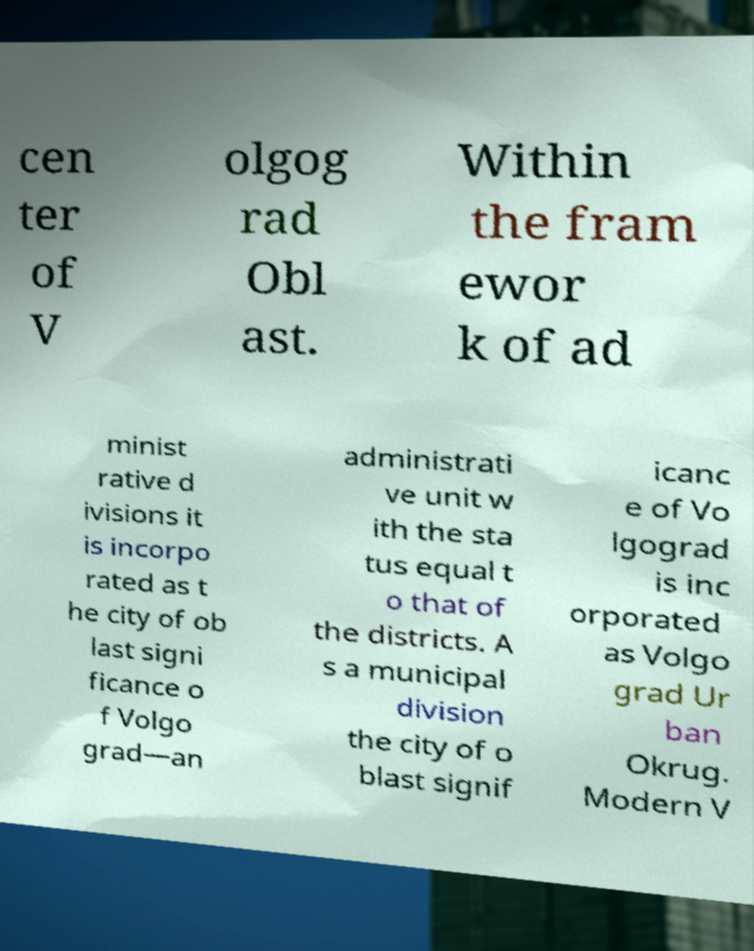Can you read and provide the text displayed in the image?This photo seems to have some interesting text. Can you extract and type it out for me? cen ter of V olgog rad Obl ast. Within the fram ewor k of ad minist rative d ivisions it is incorpo rated as t he city of ob last signi ficance o f Volgo grad—an administrati ve unit w ith the sta tus equal t o that of the districts. A s a municipal division the city of o blast signif icanc e of Vo lgograd is inc orporated as Volgo grad Ur ban Okrug. Modern V 